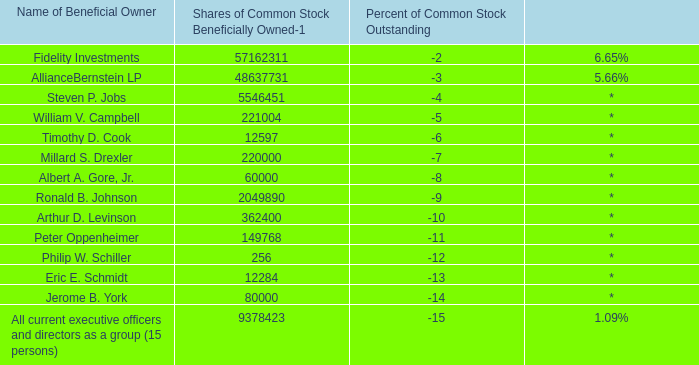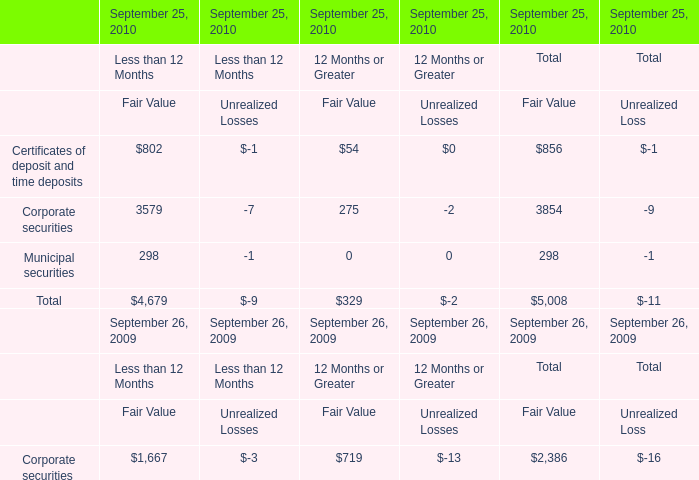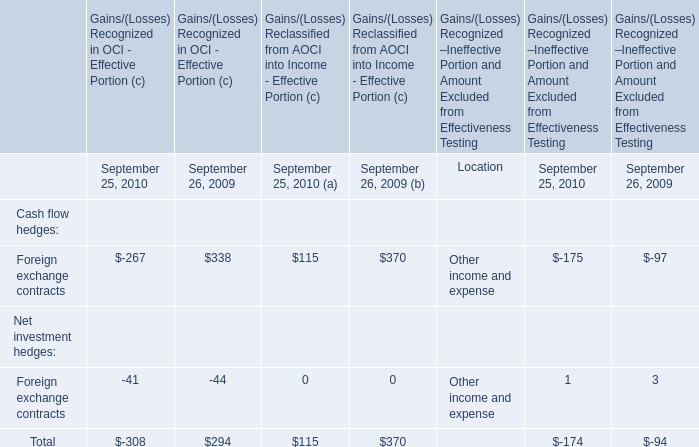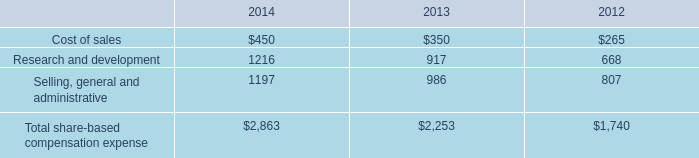Which elements for Fair Value of Total exceeds 10% of total in 2010? 
Answer: Certificates of deposit and time deposits, Corporate securities. 